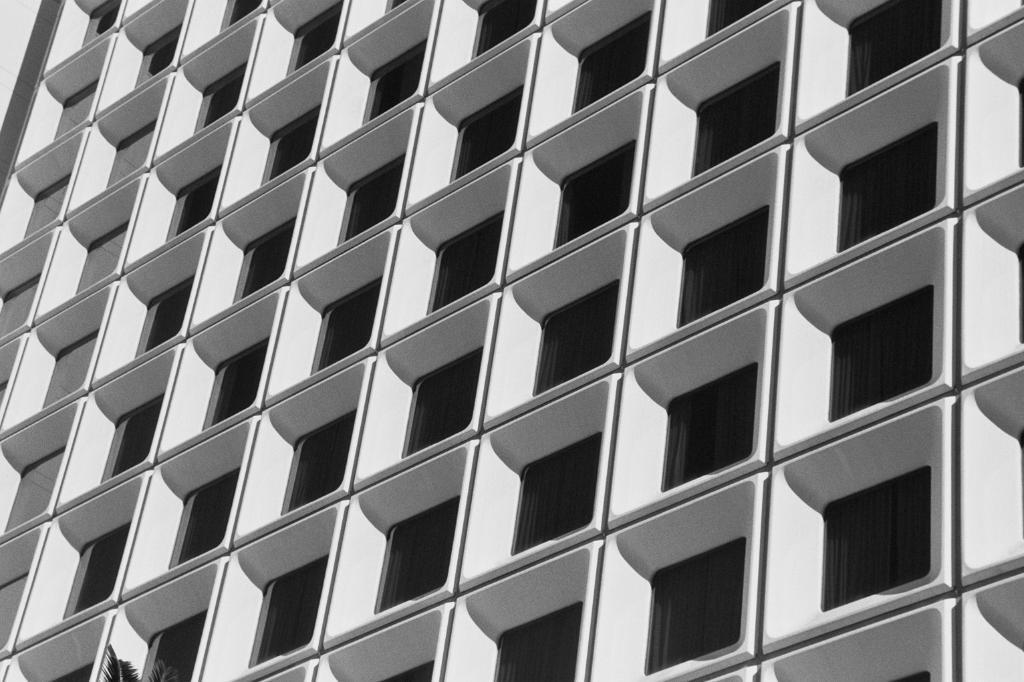Describe this image in one or two sentences. In this image we can see a building with some windows. On the bottom we can see some leaves of a tree. 